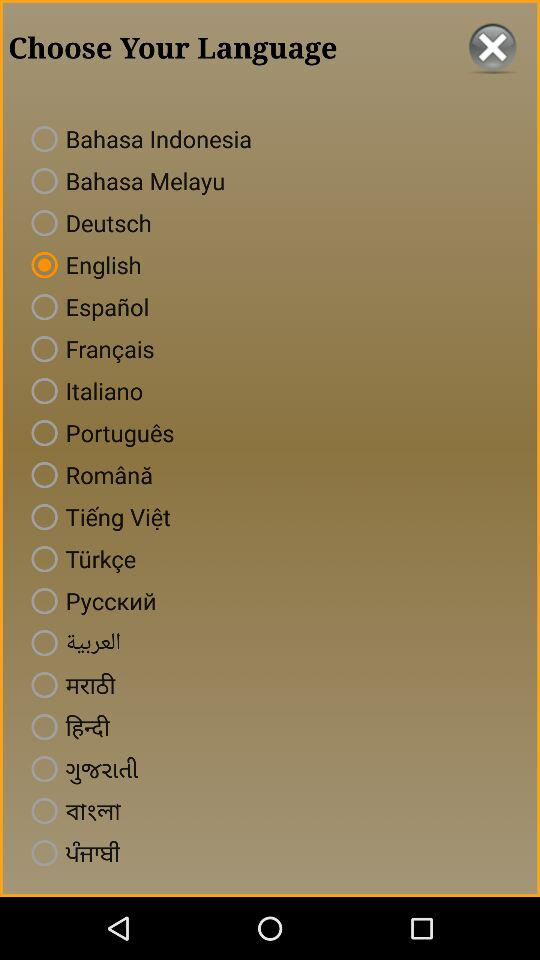Which language is selected? The selected language is English. 